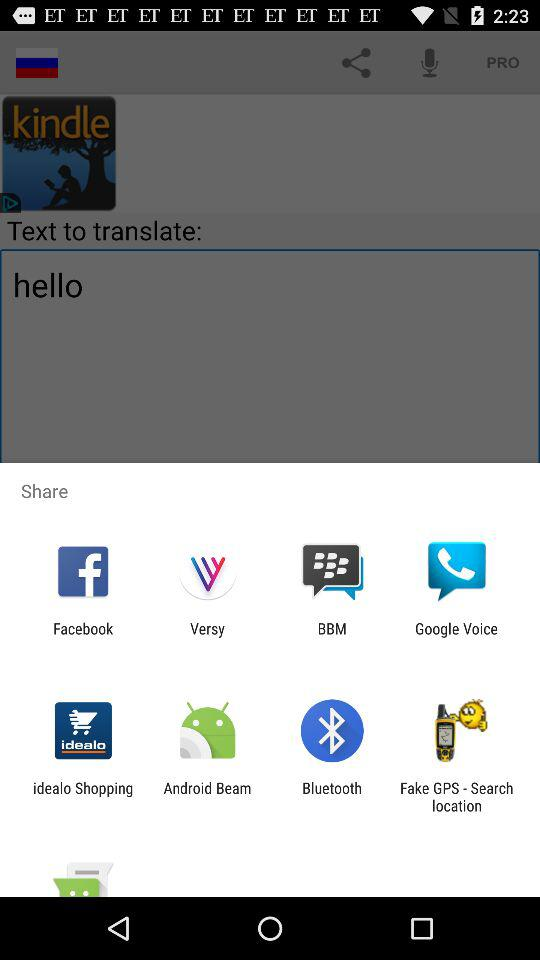Through which app can we share? You can share through "Facebook", "Versy", "BBM", "Google Voice", "idealo Shopping", "Android Beam", "Bluetooth" and "Fake GPS - Search location". 